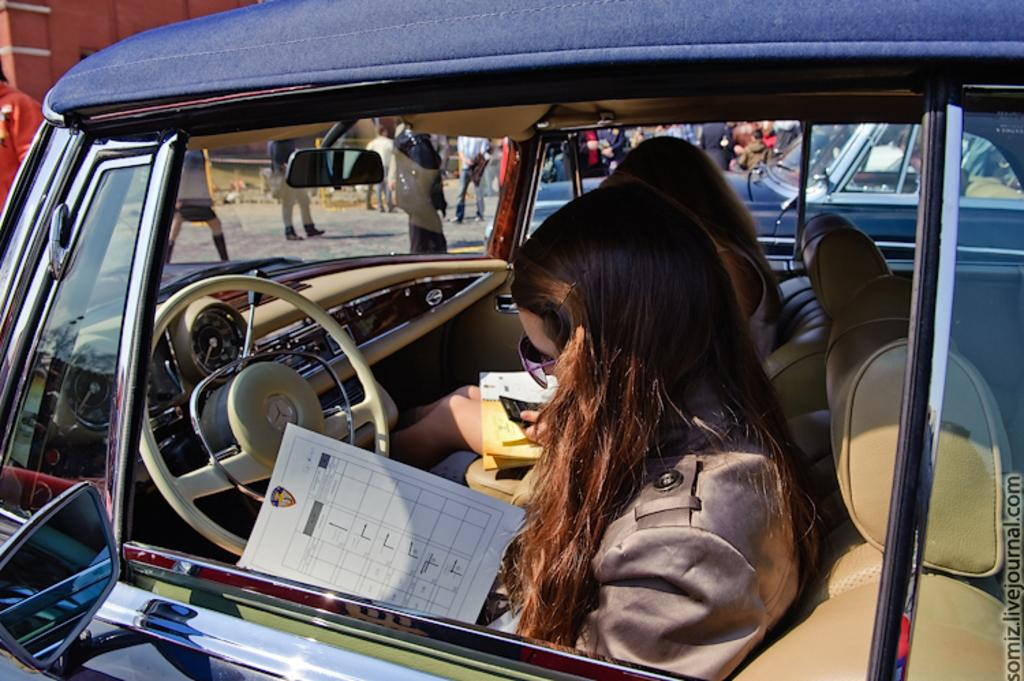What are the women in the car doing? The women are sitting inside a car and looking at a paper. What can be seen beside the car? There is another vehicle beside the car. What is happening on the road in the image? There are people walking and standing on the road. What type of lock can be seen securing the tent in the image? There is no tent or lock present in the image. How many trains are visible in the image? There are no trains visible in the image. 